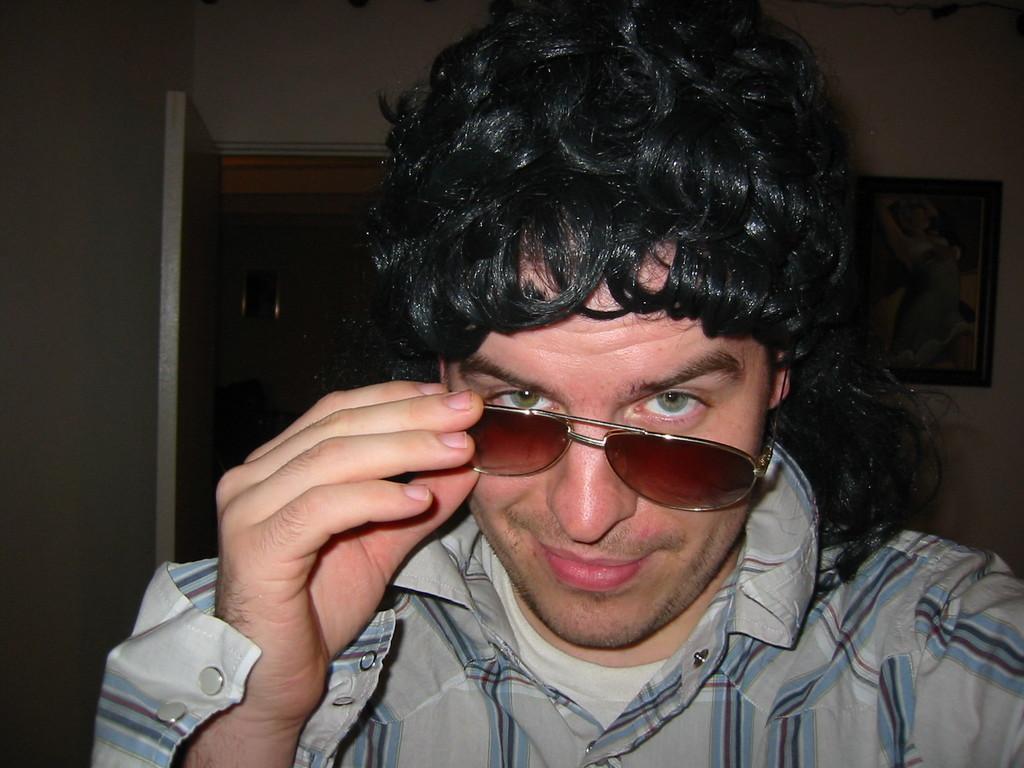How would you summarize this image in a sentence or two? In this image we can see a person wearing shirt, T-shirt and glasses is smiling. The background of the image is dark, where we can see a door and the photo frame to the wall. 